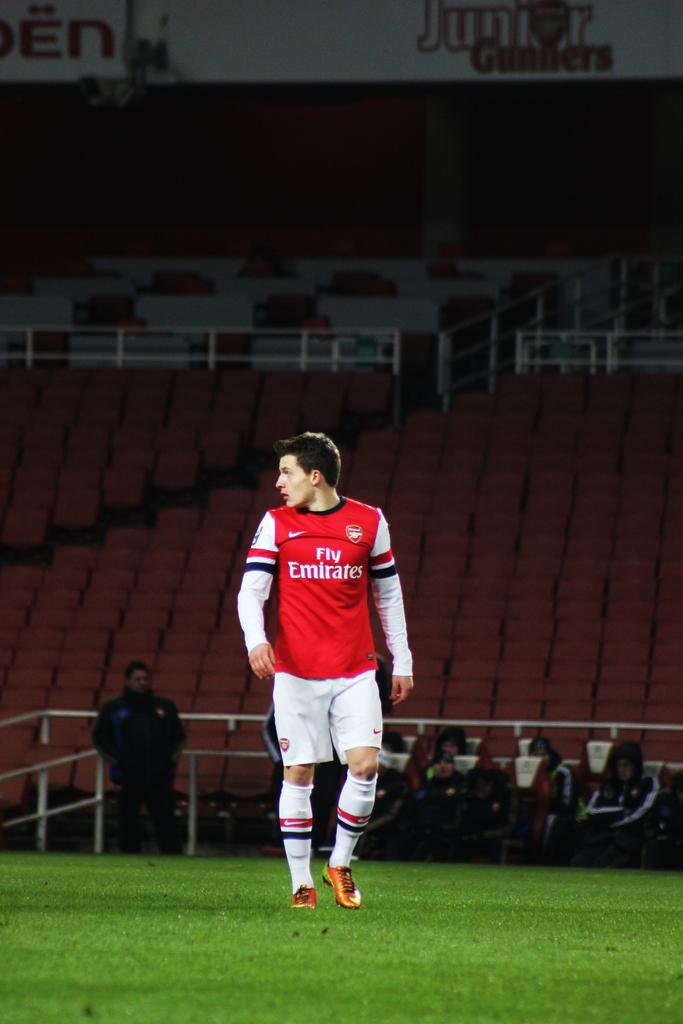<image>
Render a clear and concise summary of the photo. A play on the Fly Emirates team looks over one shoulder as he walks on the field. 